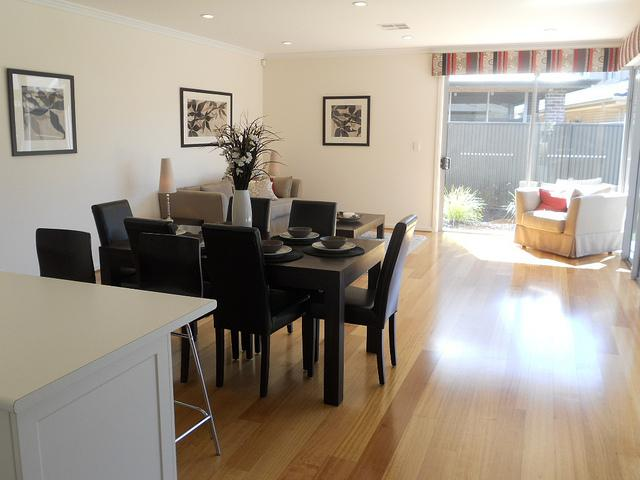What color is the seat on the couch in the corner window?

Choices:
A) blue
B) white
C) yellow
D) red white 